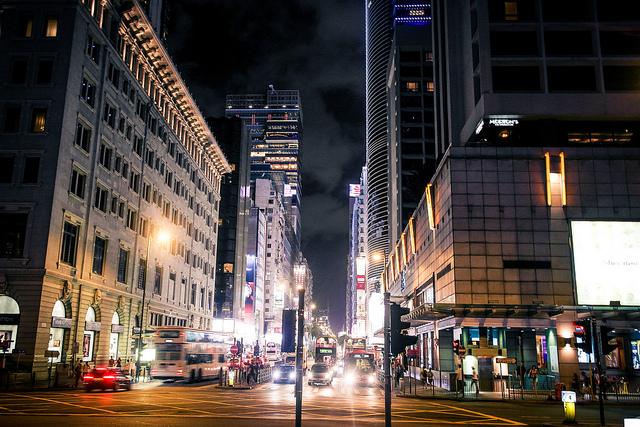Are most of the lights on or off in the building on the left?
Give a very brief answer. Off. How do you know this city is not in the United States?
Answer briefly. Driving on left side of road. Is this the suburbs or the city?
Keep it brief. City. 